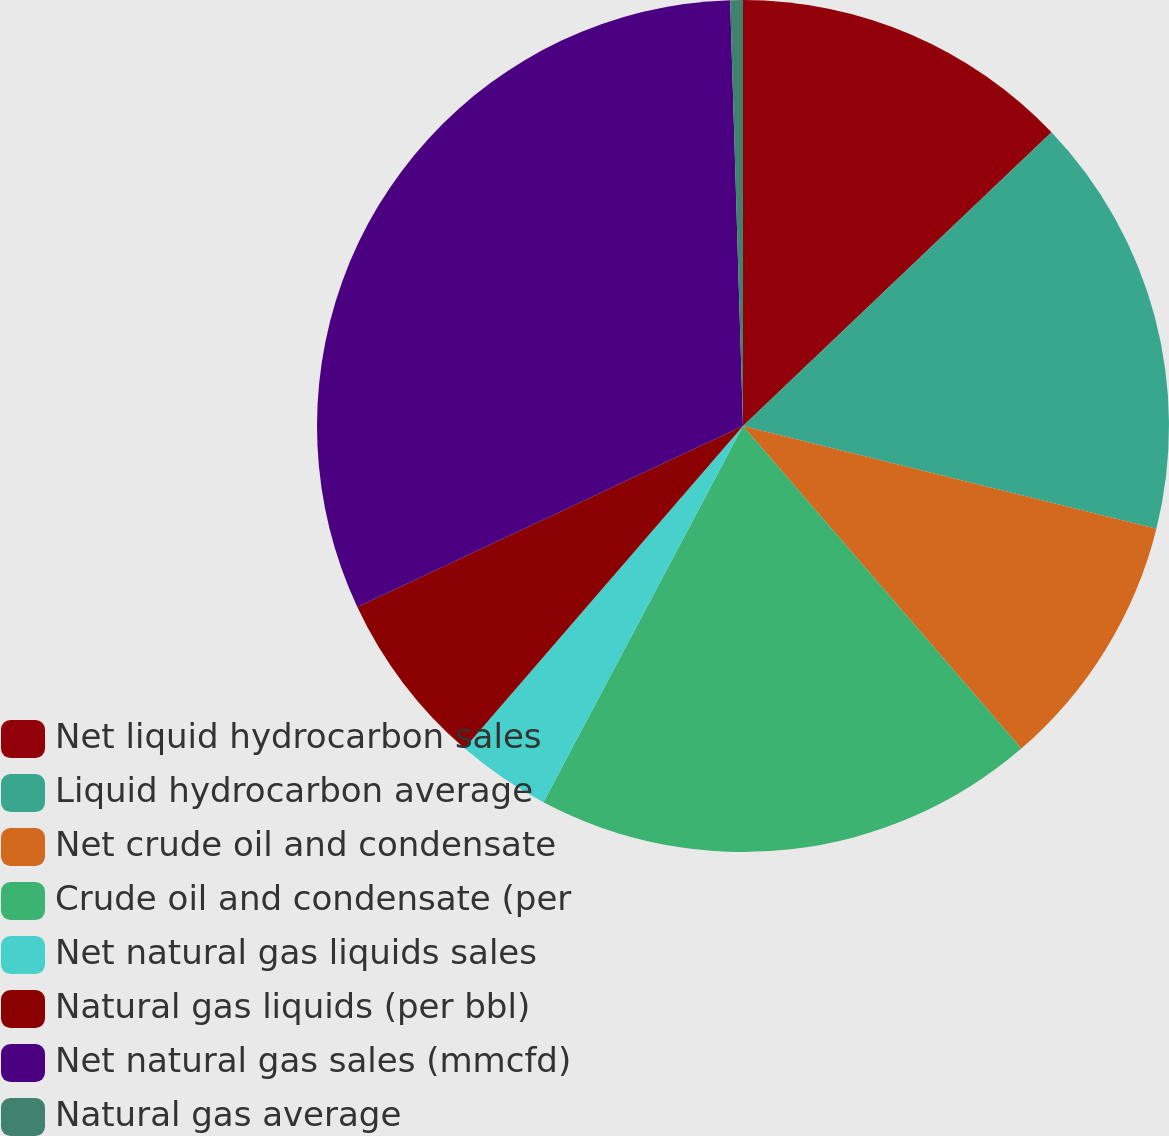Convert chart to OTSL. <chart><loc_0><loc_0><loc_500><loc_500><pie_chart><fcel>Net liquid hydrocarbon sales<fcel>Liquid hydrocarbon average<fcel>Net crude oil and condensate<fcel>Crude oil and condensate (per<fcel>Net natural gas liquids sales<fcel>Natural gas liquids (per bbl)<fcel>Net natural gas sales (mmcfd)<fcel>Natural gas average<nl><fcel>12.89%<fcel>15.99%<fcel>9.79%<fcel>19.09%<fcel>3.58%<fcel>6.68%<fcel>31.5%<fcel>0.48%<nl></chart> 